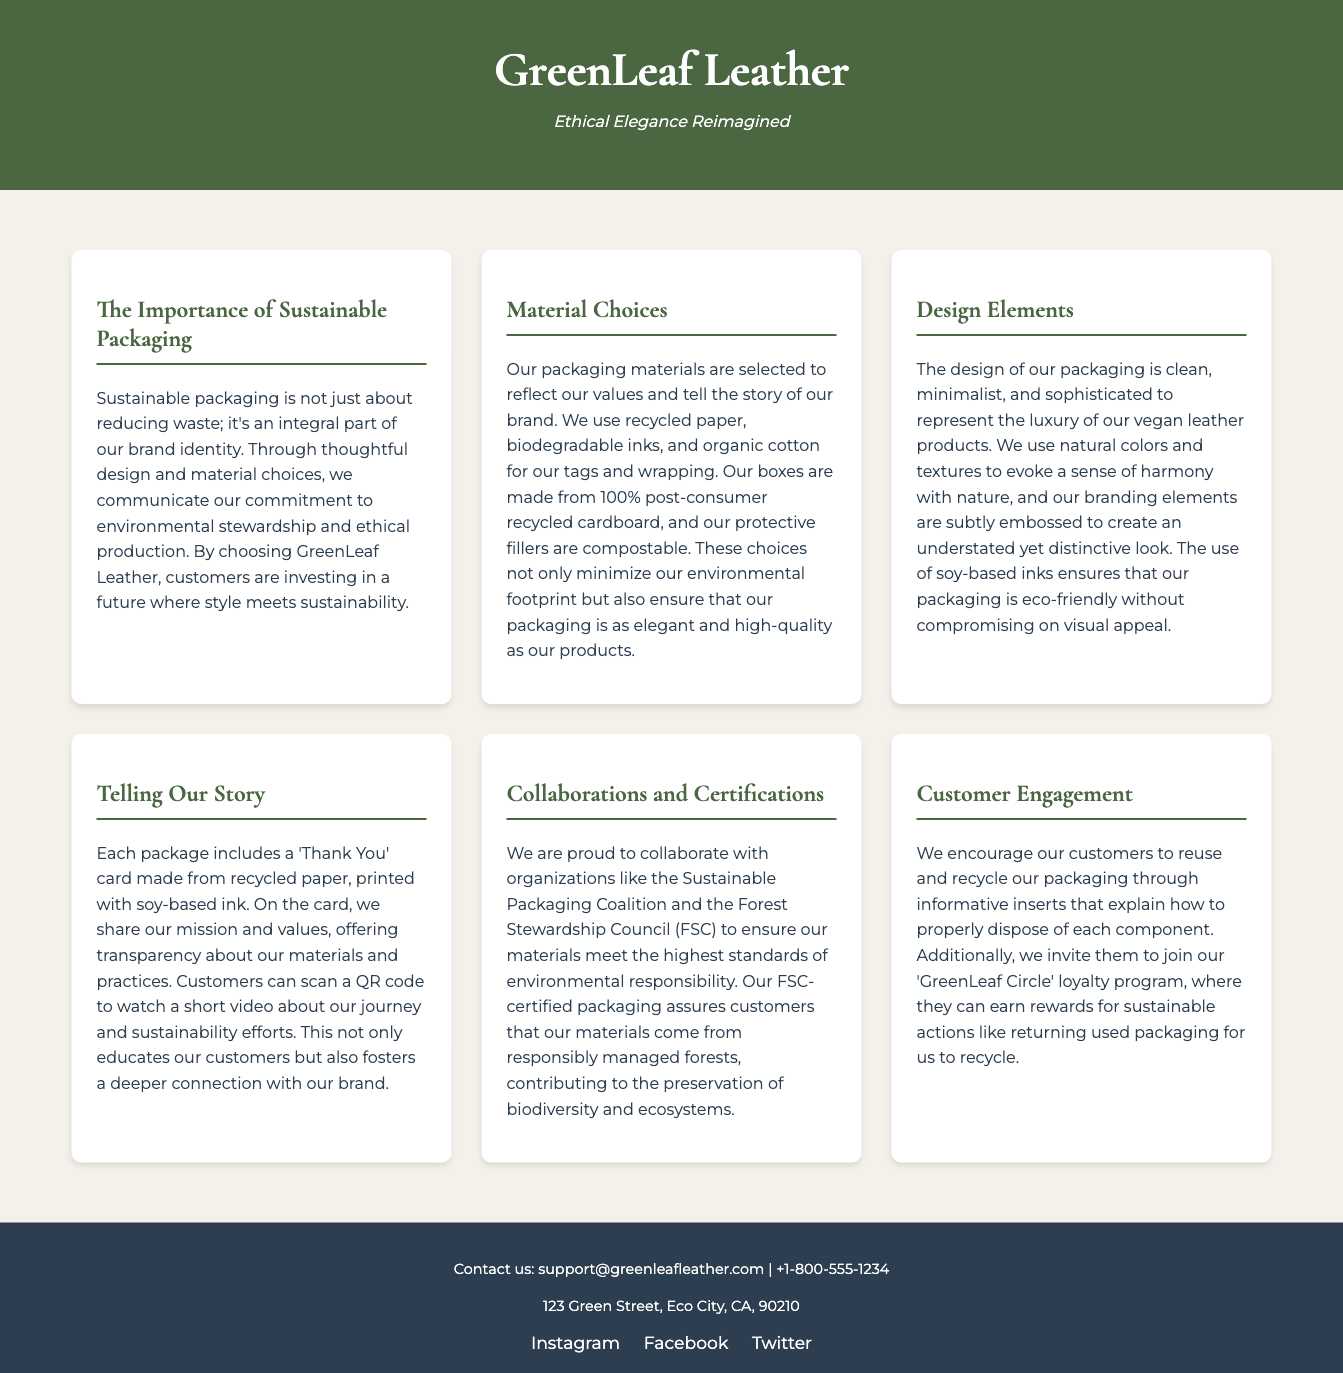What is the name of the company? The company name is prominently displayed at the top of the document in the header section.
Answer: GreenLeaf Leather What materials are used for the packaging boxes? The document explicitly states the material used for boxes in the section about material choices.
Answer: 100% post-consumer recycled cardboard What organization is mentioned for collaboration regarding packaging? The document mentions specific organizations in the collaborations and certifications section; one is highlighted.
Answer: Sustainable Packaging Coalition What type of ink is used for printing the 'Thank You' card? The document specifies the type of ink used on the 'Thank You' card in the telling our story section.
Answer: Soy-based ink How can customers participate in recycling used packaging? The document describes a specific program inviting customers to take action regarding packaging disposal.
Answer: 'GreenLeaf Circle' loyalty program What is the brand’s design style described as? The document describes a characteristic of the packaging design in relation to the vegan leather products.
Answer: Clean, minimalist, and sophisticated What is one of the key values communicated through sustainable packaging? The document emphasizes the importance of values conveyed in the sustainable packaging section.
Answer: Environmental stewardship 